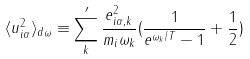Convert formula to latex. <formula><loc_0><loc_0><loc_500><loc_500>\langle u _ { i \alpha } ^ { 2 } \rangle _ { d \omega } \equiv \sum _ { k } ^ { \prime } \frac { e _ { i \alpha , k } ^ { 2 } } { m _ { i } \omega _ { k } } ( \frac { 1 } { e ^ { \omega _ { k } / T } - 1 } + \frac { 1 } { 2 } )</formula> 